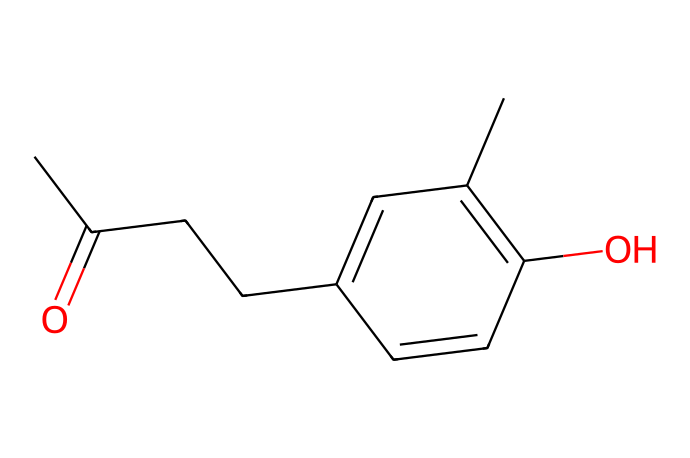How many carbon atoms are in raspberry ketone? By analyzing the SMILES representation, we count the number of "C" characters, which represent carbon atoms. There are 10 carbon atoms in total.
Answer: 10 What type of chemical compound is raspberry ketone? The chemical structure contains a carbonyl group (C=O) and an alkyl chain, which identifies it as a ketone.
Answer: ketone How many double bonds are present in raspberry ketone? Observing the structure, there are two double bonds: one in the carbonyl group and another in the aromatic ring.
Answer: 2 Does raspberry ketone contain any hydroxyl groups? The presence of "O" in the context of a hydroxyl (–OH) group is noted in the structure, indicating there is one hydroxyl group attached to the aromatic ring.
Answer: 1 What is the functional group responsible for the flavoring property in raspberry ketone? The carbonyl group (C=O) is a characteristic functional group in ketones that is largely responsible for their flavoring properties.
Answer: carbonyl group 